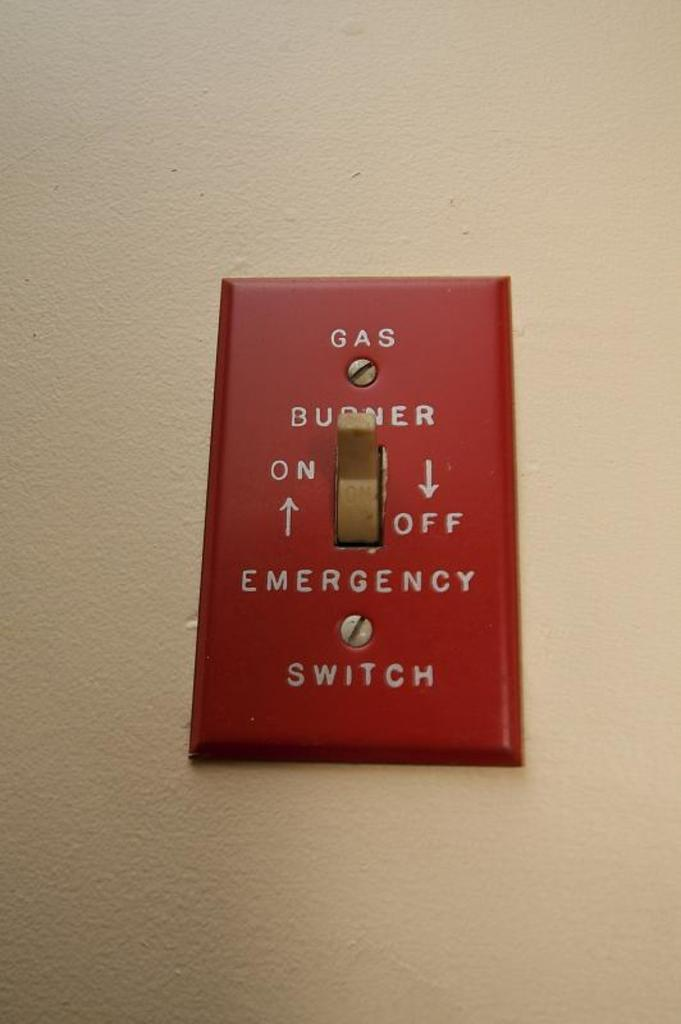Provide a one-sentence caption for the provided image. A red switch for tuning on and off the gas burner. 